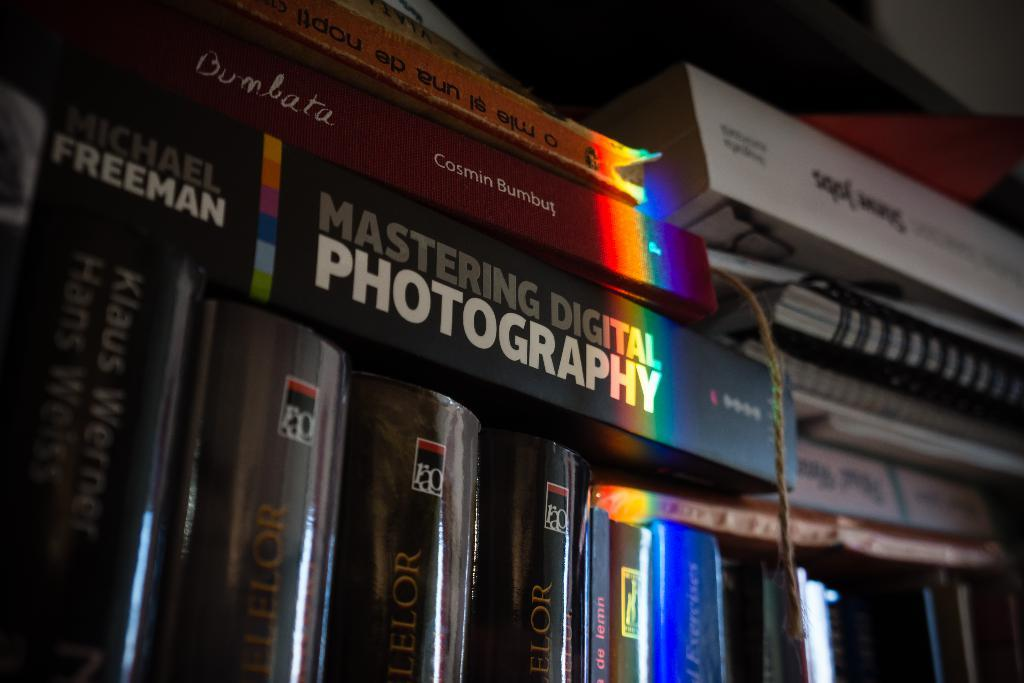What object is present in the image? There is a book in the image. What can be said about the background of the image? The background of the image is dark. What type of feeling is the book expressing in the image? The book is an inanimate object and cannot express feelings. What type of tools might a carpenter use in the image? There is no carpenter or tools present in the image. What type of road can be seen in the image? There is no road present in the image. 